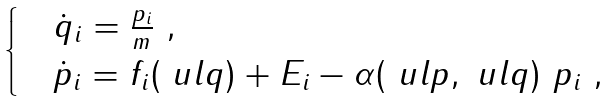<formula> <loc_0><loc_0><loc_500><loc_500>\begin{cases} & \dot { q } _ { i } = \frac { p _ { i } } { m } \ , \\ & \dot { p } _ { i } = f _ { i } ( \ u l q ) + E _ { i } - \alpha ( \ u l p , \ u l q ) \ p _ { i } \ , \end{cases}</formula> 